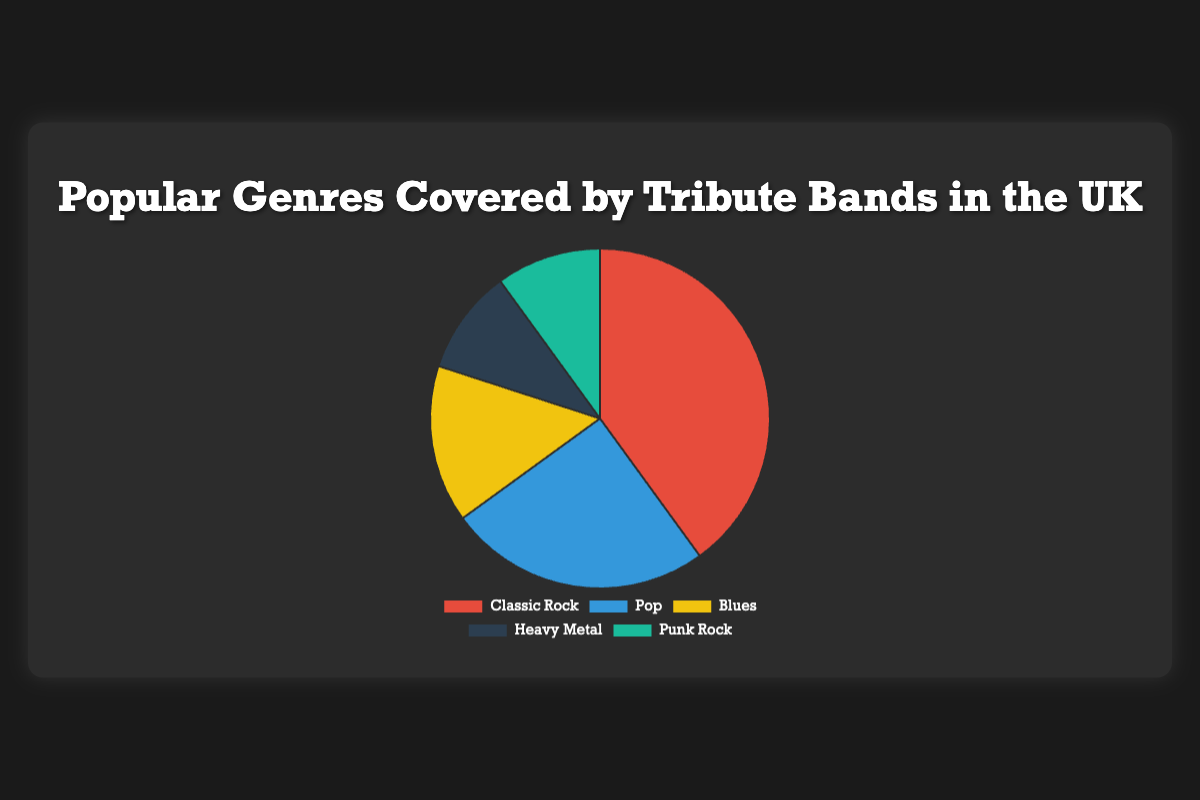What's the most popular genre covered by tribute bands in the UK? The Classic Rock genre has the largest section in the pie chart, indicating it's the most popular.
Answer: Classic Rock Which genre has the smallest percentage of coverage by tribute bands? Both Heavy Metal and Punk Rock sections have equal and smallest portions in the pie chart.
Answer: Heavy Metal and Punk Rock How much larger is the percentage of Classic Rock compared to Blues covered by tribute bands? Classic Rock is 40%, and Blues is 15%. The difference is 40% - 15% = 25%.
Answer: 25% Which genres combined cover 20% of the pie chart? Heavy Metal and Punk Rock both are 10%, so 10% + 10% = 20%.
Answer: Heavy Metal and Punk Rock What is the total percentage covered by non-Rock genres? Non-Rock genres are Pop and Blues. So, Pop is 25% and Blues is 15%. Therefore, 25% + 15% = 40%.
Answer: 40% How does the coverage of Pop compare to Heavy Metal and Punk Rock combined? Pop is 25%, while Heavy Metal and Punk Rock combined is 10% + 10% = 20%. Pop is 5% more.
Answer: Pop is 5% more If the percentage of Pop were doubled, what would its new percentage be? Pop is currently 25%, doubling it would be 25% × 2 = 50%.
Answer: 50% Given the genres presented, which one is covered more than twice as much as Punk Rock? Classic Rock is 40%, which is more than twice the amount of Punk Rock which is 10%. 40% is greater than 10% × 2.
Answer: Classic Rock What's the average percentage of coverage across all genres listed? The percentages are 40%, 25%, 15%, 10%, 10%. The sum is (40+25+15+10+10) = 100. The number of genres is 5, so the average is 100 / 5 = 20%.
Answer: 20% What fraction of the total coverage is composed of Heavy Metal? Heavy Metal is 10%, and the total is 100%. Converting this to a fraction, we get 10/100 = 1/10.
Answer: 1/10 